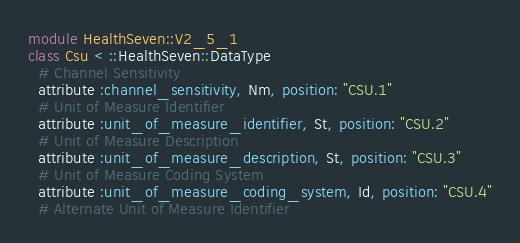Convert code to text. <code><loc_0><loc_0><loc_500><loc_500><_Ruby_>module HealthSeven::V2_5_1
class Csu < ::HealthSeven::DataType
  # Channel Sensitivity
  attribute :channel_sensitivity, Nm, position: "CSU.1"
  # Unit of Measure Identifier
  attribute :unit_of_measure_identifier, St, position: "CSU.2"
  # Unit of Measure Description
  attribute :unit_of_measure_description, St, position: "CSU.3"
  # Unit of Measure Coding System
  attribute :unit_of_measure_coding_system, Id, position: "CSU.4"
  # Alternate Unit of Measure Identifier</code> 